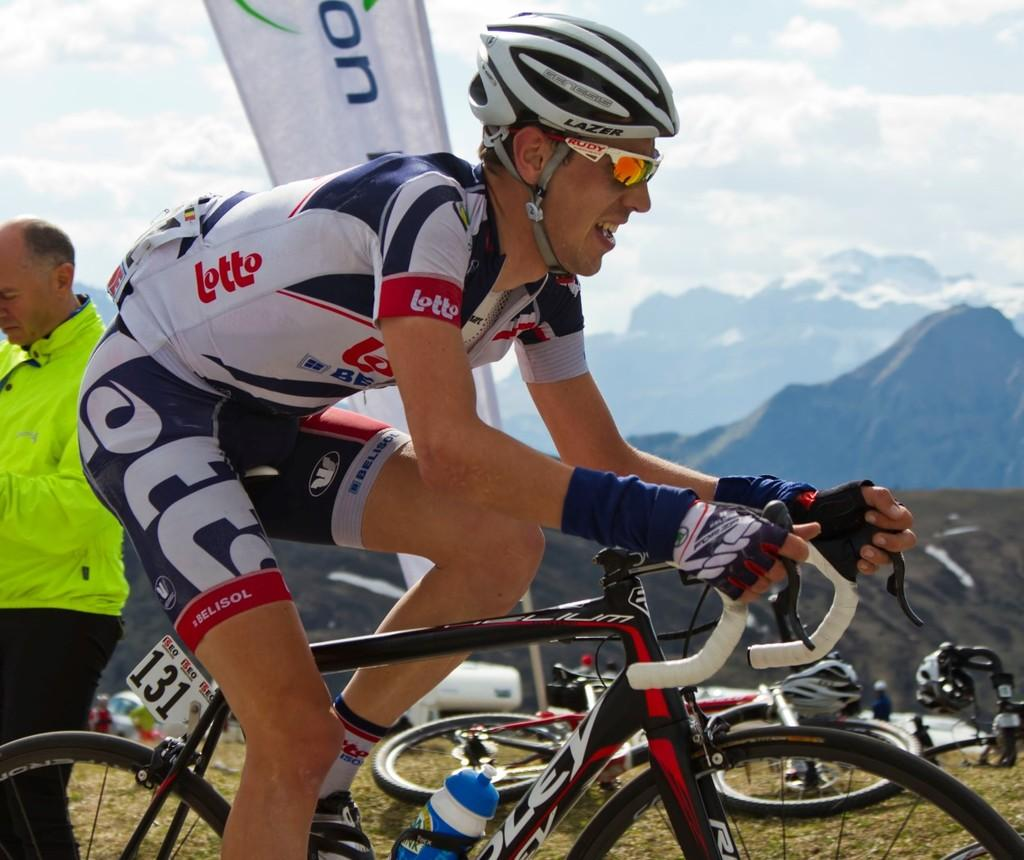Who is present in the image? There is a person in the image. What is the person wearing? The person is wearing a helmet. What activity is the person engaged in? The person is riding a bicycle. What can be seen in the background of the image? There are mountains and a cloudy sky in the background. What other objects are visible in the image? There is a bicycle, a hoarding, a number board, and a bottle in the image. How many ladybugs can be seen on the wheel of the bicycle in the image? There are no ladybugs present in the image, and therefore no such activity can be observed. 